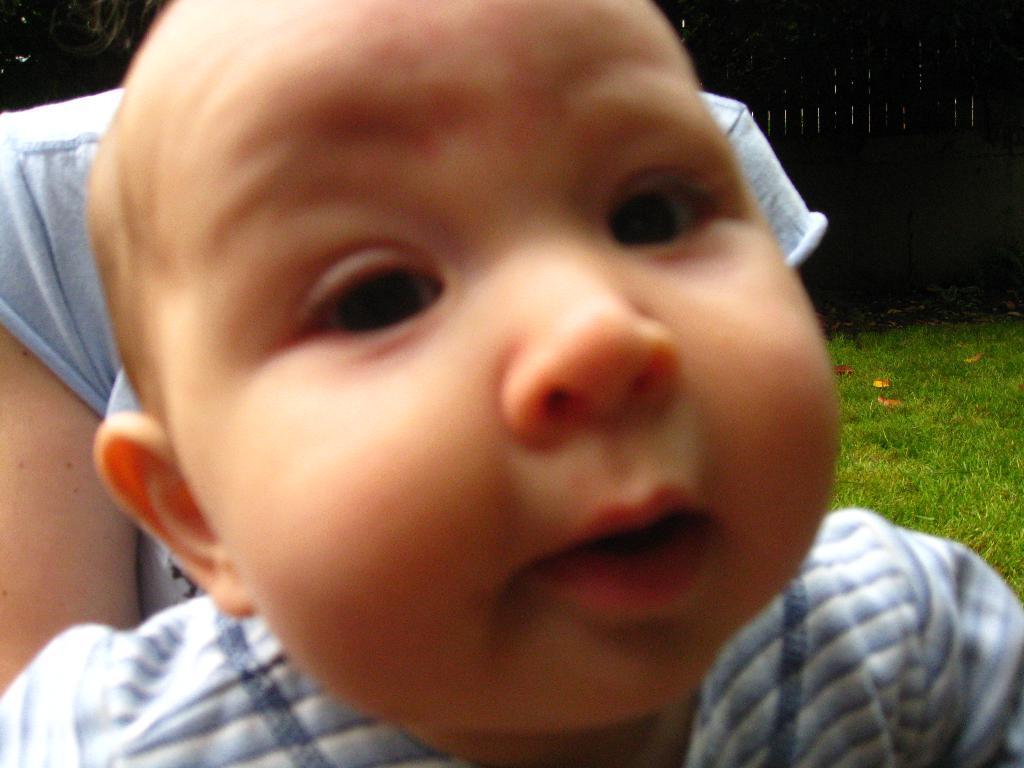Describe this image in one or two sentences. In this picture there is a small baby looking into the camera. Behind there is a woman holding him. In the background there is a grass field. 